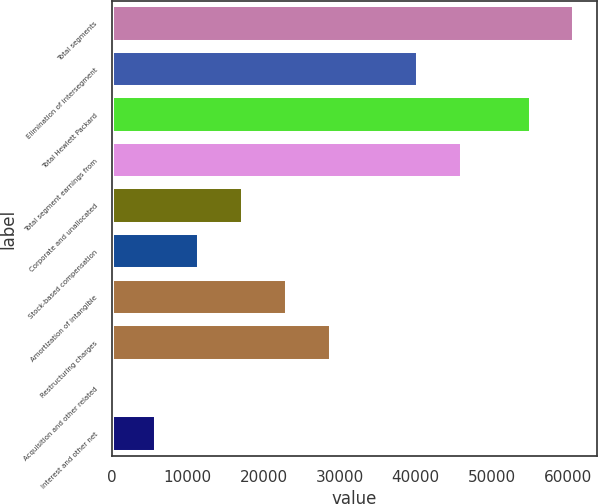Convert chart to OTSL. <chart><loc_0><loc_0><loc_500><loc_500><bar_chart><fcel>Total segments<fcel>Elimination of intersegment<fcel>Total Hewlett Packard<fcel>Total segment earnings from<fcel>Corporate and unallocated<fcel>Stock-based compensation<fcel>Amortization of intangible<fcel>Restructuring charges<fcel>Acquisition and other related<fcel>Interest and other net<nl><fcel>60877.9<fcel>40295.3<fcel>55123<fcel>46050.2<fcel>17275.7<fcel>11520.8<fcel>23030.6<fcel>28785.5<fcel>11<fcel>5765.9<nl></chart> 